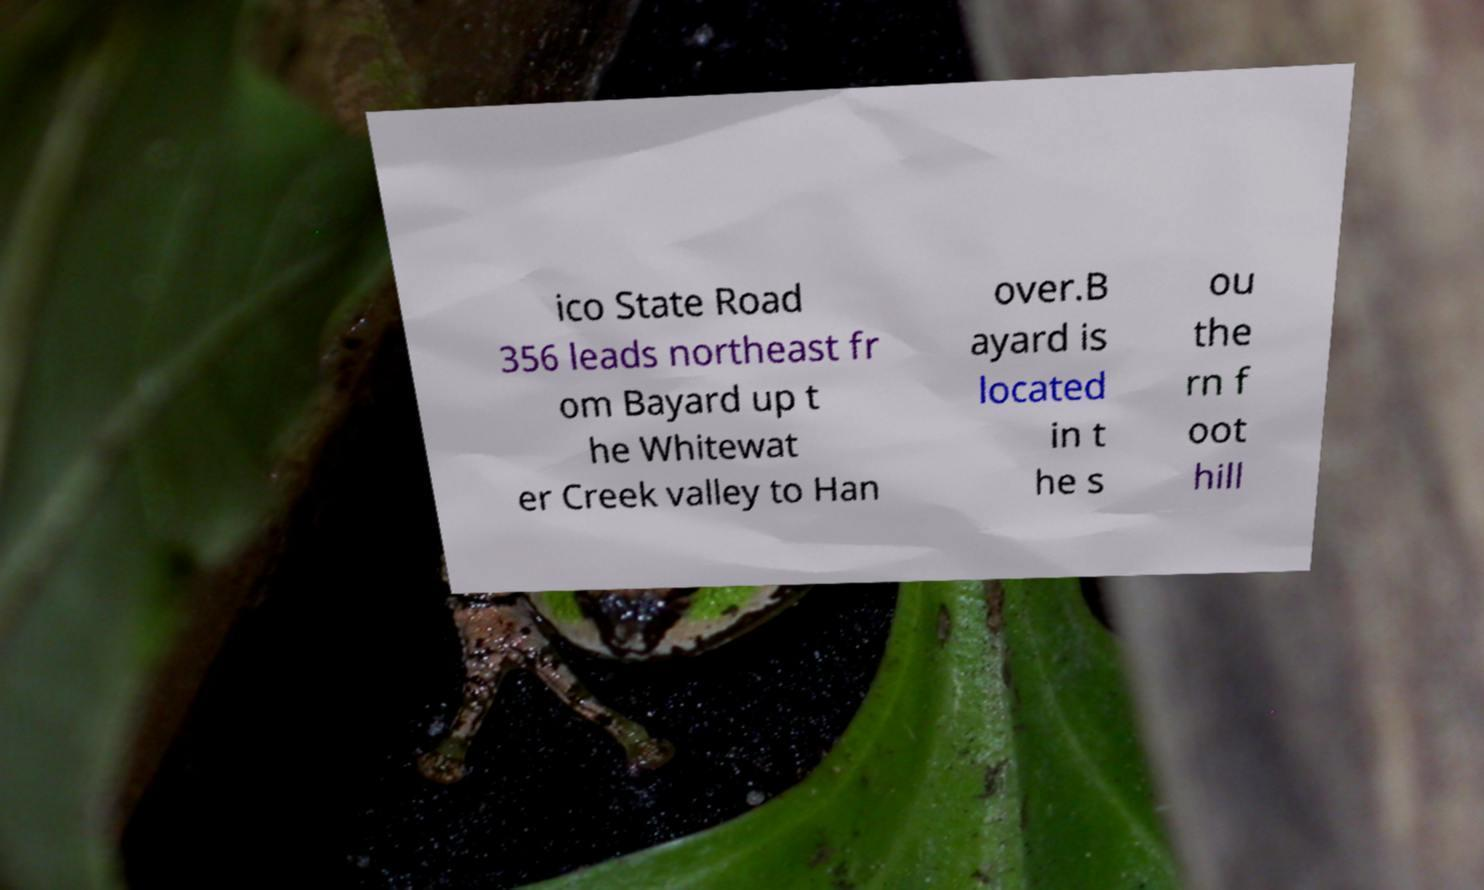I need the written content from this picture converted into text. Can you do that? ico State Road 356 leads northeast fr om Bayard up t he Whitewat er Creek valley to Han over.B ayard is located in t he s ou the rn f oot hill 